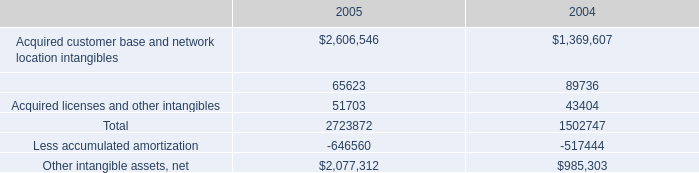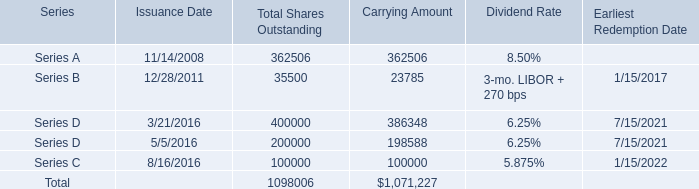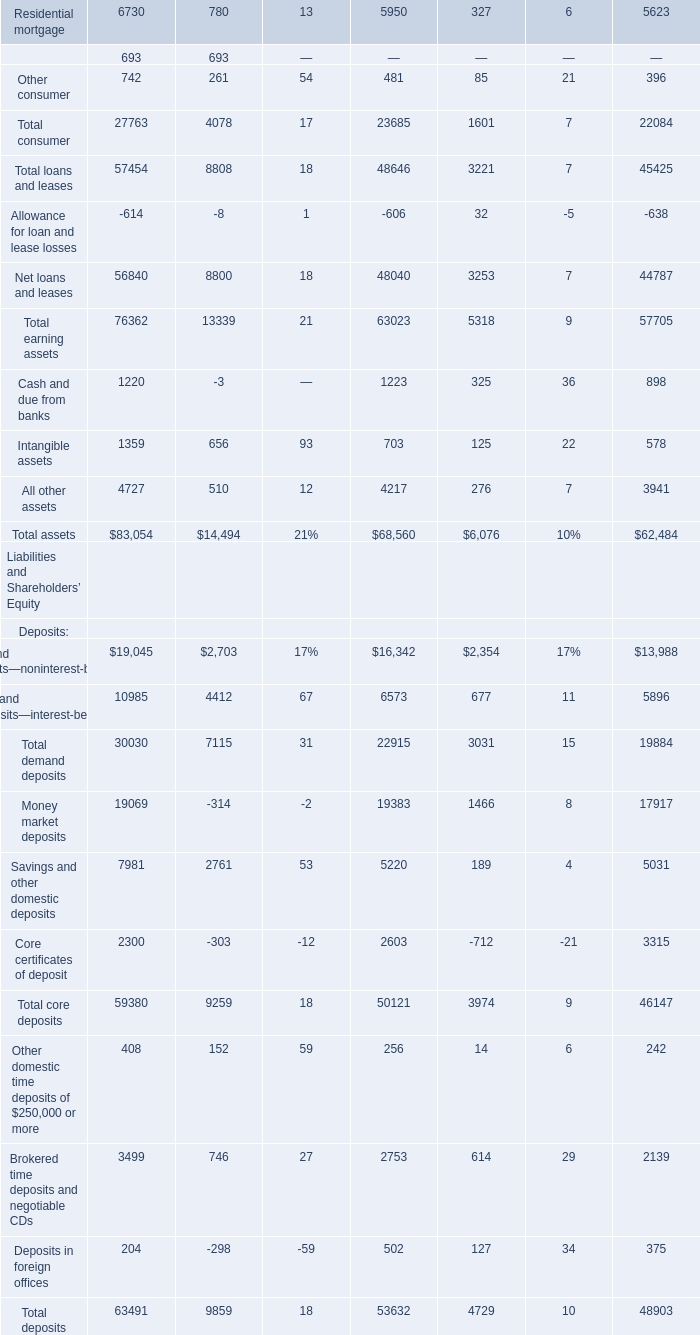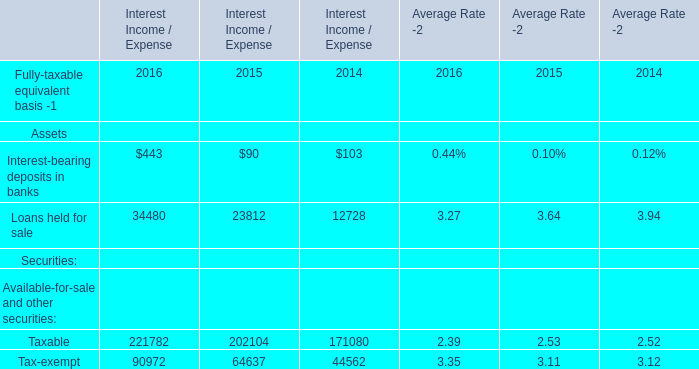what was the percentage of the increase in the customer intangible asset from 2004 to 2005 
Computations: ((2723872 - 1502747) / 1502747)
Answer: 0.8126. 